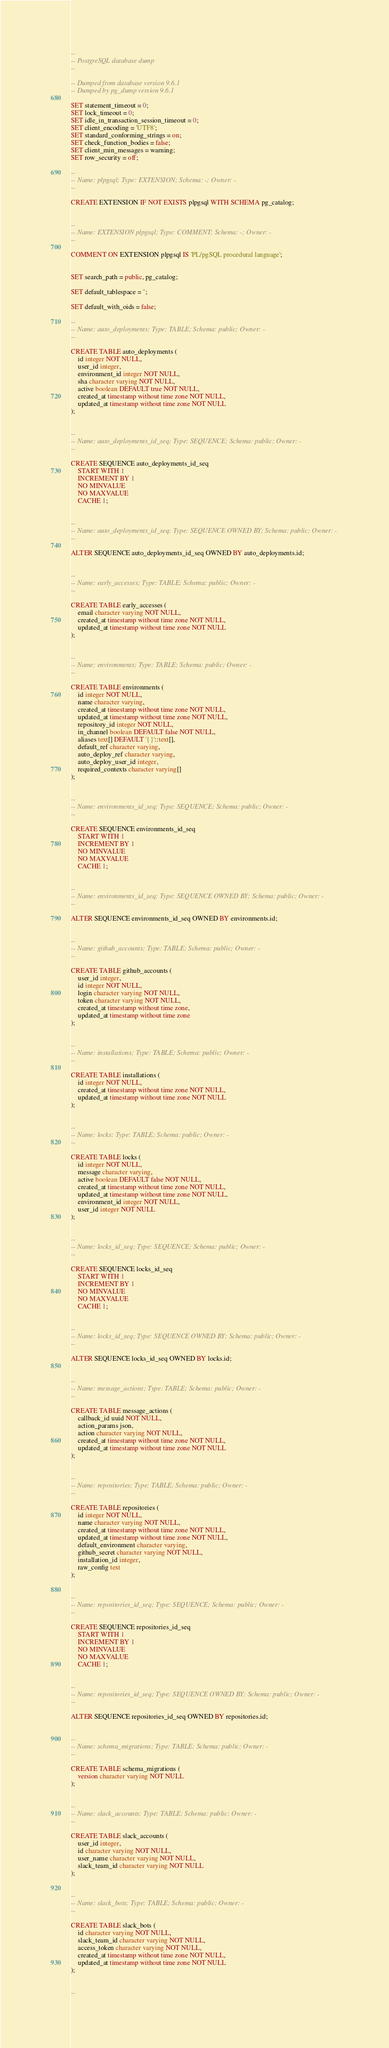Convert code to text. <code><loc_0><loc_0><loc_500><loc_500><_SQL_>--
-- PostgreSQL database dump
--

-- Dumped from database version 9.6.1
-- Dumped by pg_dump version 9.6.1

SET statement_timeout = 0;
SET lock_timeout = 0;
SET idle_in_transaction_session_timeout = 0;
SET client_encoding = 'UTF8';
SET standard_conforming_strings = on;
SET check_function_bodies = false;
SET client_min_messages = warning;
SET row_security = off;

--
-- Name: plpgsql; Type: EXTENSION; Schema: -; Owner: -
--

CREATE EXTENSION IF NOT EXISTS plpgsql WITH SCHEMA pg_catalog;


--
-- Name: EXTENSION plpgsql; Type: COMMENT; Schema: -; Owner: -
--

COMMENT ON EXTENSION plpgsql IS 'PL/pgSQL procedural language';


SET search_path = public, pg_catalog;

SET default_tablespace = '';

SET default_with_oids = false;

--
-- Name: auto_deployments; Type: TABLE; Schema: public; Owner: -
--

CREATE TABLE auto_deployments (
    id integer NOT NULL,
    user_id integer,
    environment_id integer NOT NULL,
    sha character varying NOT NULL,
    active boolean DEFAULT true NOT NULL,
    created_at timestamp without time zone NOT NULL,
    updated_at timestamp without time zone NOT NULL
);


--
-- Name: auto_deployments_id_seq; Type: SEQUENCE; Schema: public; Owner: -
--

CREATE SEQUENCE auto_deployments_id_seq
    START WITH 1
    INCREMENT BY 1
    NO MINVALUE
    NO MAXVALUE
    CACHE 1;


--
-- Name: auto_deployments_id_seq; Type: SEQUENCE OWNED BY; Schema: public; Owner: -
--

ALTER SEQUENCE auto_deployments_id_seq OWNED BY auto_deployments.id;


--
-- Name: early_accesses; Type: TABLE; Schema: public; Owner: -
--

CREATE TABLE early_accesses (
    email character varying NOT NULL,
    created_at timestamp without time zone NOT NULL,
    updated_at timestamp without time zone NOT NULL
);


--
-- Name: environments; Type: TABLE; Schema: public; Owner: -
--

CREATE TABLE environments (
    id integer NOT NULL,
    name character varying,
    created_at timestamp without time zone NOT NULL,
    updated_at timestamp without time zone NOT NULL,
    repository_id integer NOT NULL,
    in_channel boolean DEFAULT false NOT NULL,
    aliases text[] DEFAULT '{}'::text[],
    default_ref character varying,
    auto_deploy_ref character varying,
    auto_deploy_user_id integer,
    required_contexts character varying[]
);


--
-- Name: environments_id_seq; Type: SEQUENCE; Schema: public; Owner: -
--

CREATE SEQUENCE environments_id_seq
    START WITH 1
    INCREMENT BY 1
    NO MINVALUE
    NO MAXVALUE
    CACHE 1;


--
-- Name: environments_id_seq; Type: SEQUENCE OWNED BY; Schema: public; Owner: -
--

ALTER SEQUENCE environments_id_seq OWNED BY environments.id;


--
-- Name: github_accounts; Type: TABLE; Schema: public; Owner: -
--

CREATE TABLE github_accounts (
    user_id integer,
    id integer NOT NULL,
    login character varying NOT NULL,
    token character varying NOT NULL,
    created_at timestamp without time zone,
    updated_at timestamp without time zone
);


--
-- Name: installations; Type: TABLE; Schema: public; Owner: -
--

CREATE TABLE installations (
    id integer NOT NULL,
    created_at timestamp without time zone NOT NULL,
    updated_at timestamp without time zone NOT NULL
);


--
-- Name: locks; Type: TABLE; Schema: public; Owner: -
--

CREATE TABLE locks (
    id integer NOT NULL,
    message character varying,
    active boolean DEFAULT false NOT NULL,
    created_at timestamp without time zone NOT NULL,
    updated_at timestamp without time zone NOT NULL,
    environment_id integer NOT NULL,
    user_id integer NOT NULL
);


--
-- Name: locks_id_seq; Type: SEQUENCE; Schema: public; Owner: -
--

CREATE SEQUENCE locks_id_seq
    START WITH 1
    INCREMENT BY 1
    NO MINVALUE
    NO MAXVALUE
    CACHE 1;


--
-- Name: locks_id_seq; Type: SEQUENCE OWNED BY; Schema: public; Owner: -
--

ALTER SEQUENCE locks_id_seq OWNED BY locks.id;


--
-- Name: message_actions; Type: TABLE; Schema: public; Owner: -
--

CREATE TABLE message_actions (
    callback_id uuid NOT NULL,
    action_params json,
    action character varying NOT NULL,
    created_at timestamp without time zone NOT NULL,
    updated_at timestamp without time zone NOT NULL
);


--
-- Name: repositories; Type: TABLE; Schema: public; Owner: -
--

CREATE TABLE repositories (
    id integer NOT NULL,
    name character varying NOT NULL,
    created_at timestamp without time zone NOT NULL,
    updated_at timestamp without time zone NOT NULL,
    default_environment character varying,
    github_secret character varying NOT NULL,
    installation_id integer,
    raw_config text
);


--
-- Name: repositories_id_seq; Type: SEQUENCE; Schema: public; Owner: -
--

CREATE SEQUENCE repositories_id_seq
    START WITH 1
    INCREMENT BY 1
    NO MINVALUE
    NO MAXVALUE
    CACHE 1;


--
-- Name: repositories_id_seq; Type: SEQUENCE OWNED BY; Schema: public; Owner: -
--

ALTER SEQUENCE repositories_id_seq OWNED BY repositories.id;


--
-- Name: schema_migrations; Type: TABLE; Schema: public; Owner: -
--

CREATE TABLE schema_migrations (
    version character varying NOT NULL
);


--
-- Name: slack_accounts; Type: TABLE; Schema: public; Owner: -
--

CREATE TABLE slack_accounts (
    user_id integer,
    id character varying NOT NULL,
    user_name character varying NOT NULL,
    slack_team_id character varying NOT NULL
);


--
-- Name: slack_bots; Type: TABLE; Schema: public; Owner: -
--

CREATE TABLE slack_bots (
    id character varying NOT NULL,
    slack_team_id character varying NOT NULL,
    access_token character varying NOT NULL,
    created_at timestamp without time zone NOT NULL,
    updated_at timestamp without time zone NOT NULL
);


--</code> 